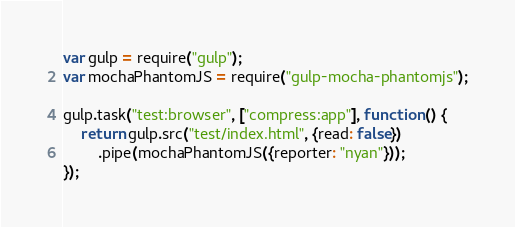Convert code to text. <code><loc_0><loc_0><loc_500><loc_500><_JavaScript_>var gulp = require("gulp");
var mochaPhantomJS = require("gulp-mocha-phantomjs");

gulp.task("test:browser", ["compress:app"], function () { 
    return gulp.src("test/index.html", {read: false})
        .pipe(mochaPhantomJS({reporter: "nyan"}));
});</code> 